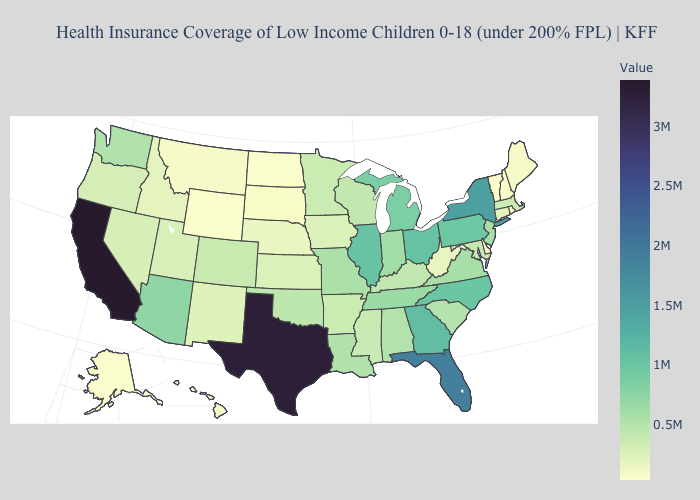Among the states that border Mississippi , does Arkansas have the lowest value?
Be succinct. Yes. Does the map have missing data?
Concise answer only. No. Does Arkansas have a higher value than Texas?
Give a very brief answer. No. Among the states that border Idaho , which have the highest value?
Quick response, please. Washington. Which states have the lowest value in the USA?
Concise answer only. Vermont. 